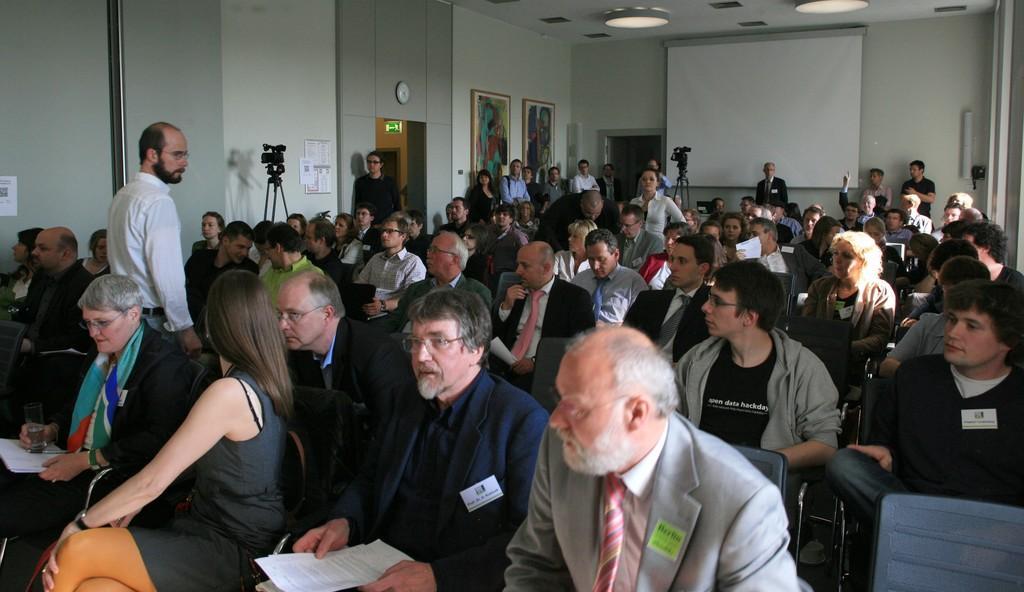Can you describe this image briefly? This image looks like it is clicked in a conference hall. There are many people sitting in the chairs. To the left there is a stand alone with camera. In the background, there is a wall on which frames and a clock is fixed. To the the right there is a projector screen. 